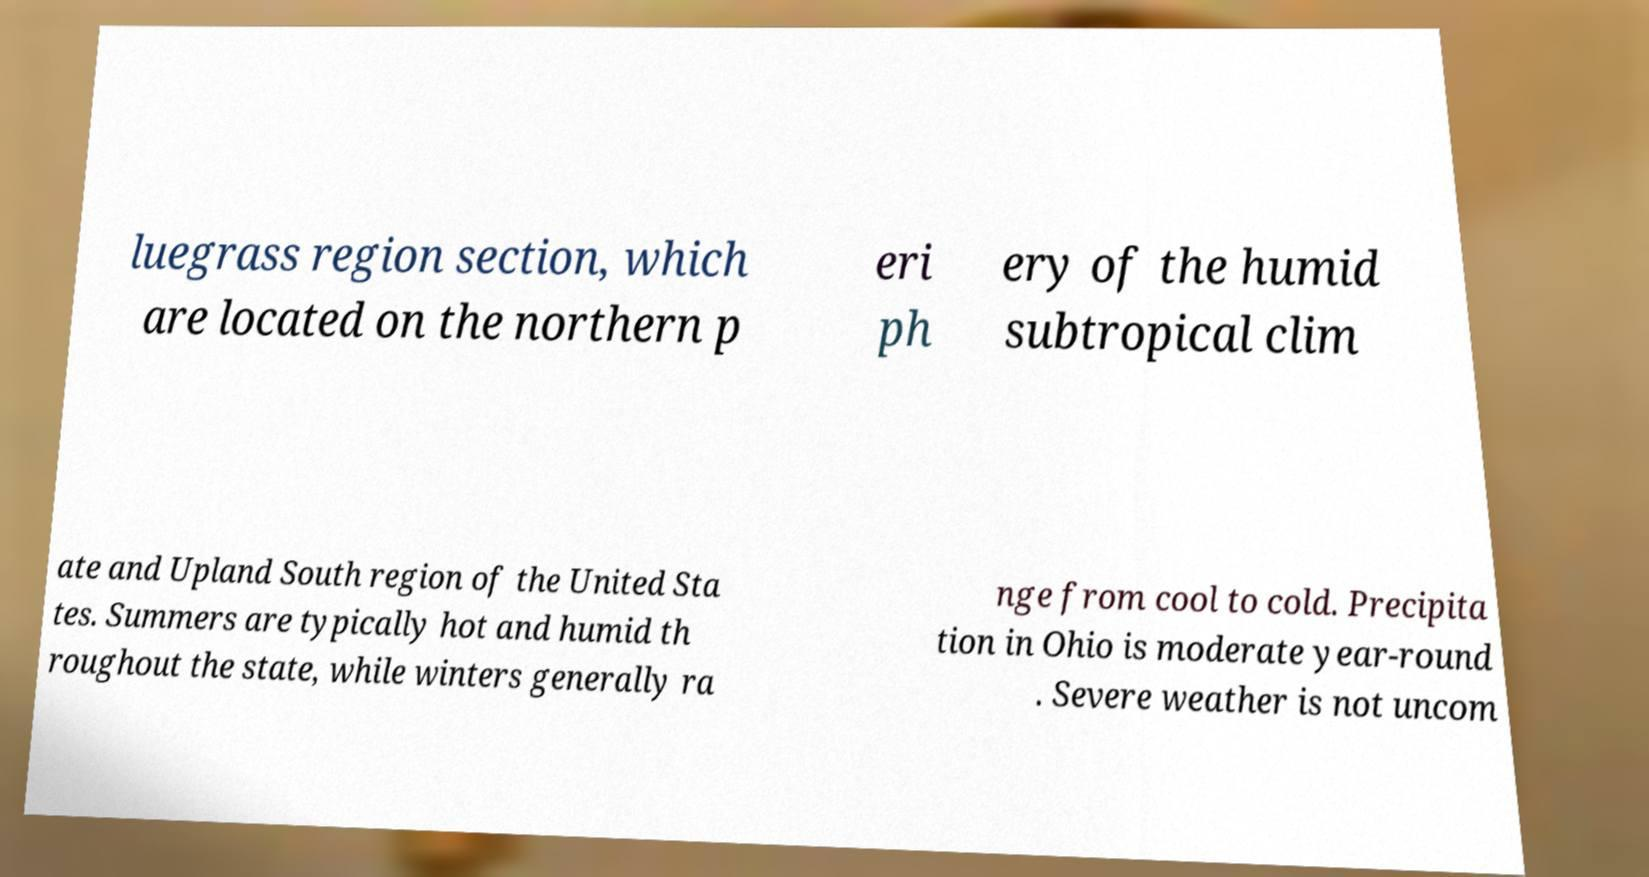Can you read and provide the text displayed in the image?This photo seems to have some interesting text. Can you extract and type it out for me? luegrass region section, which are located on the northern p eri ph ery of the humid subtropical clim ate and Upland South region of the United Sta tes. Summers are typically hot and humid th roughout the state, while winters generally ra nge from cool to cold. Precipita tion in Ohio is moderate year-round . Severe weather is not uncom 